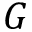Convert formula to latex. <formula><loc_0><loc_0><loc_500><loc_500>G</formula> 